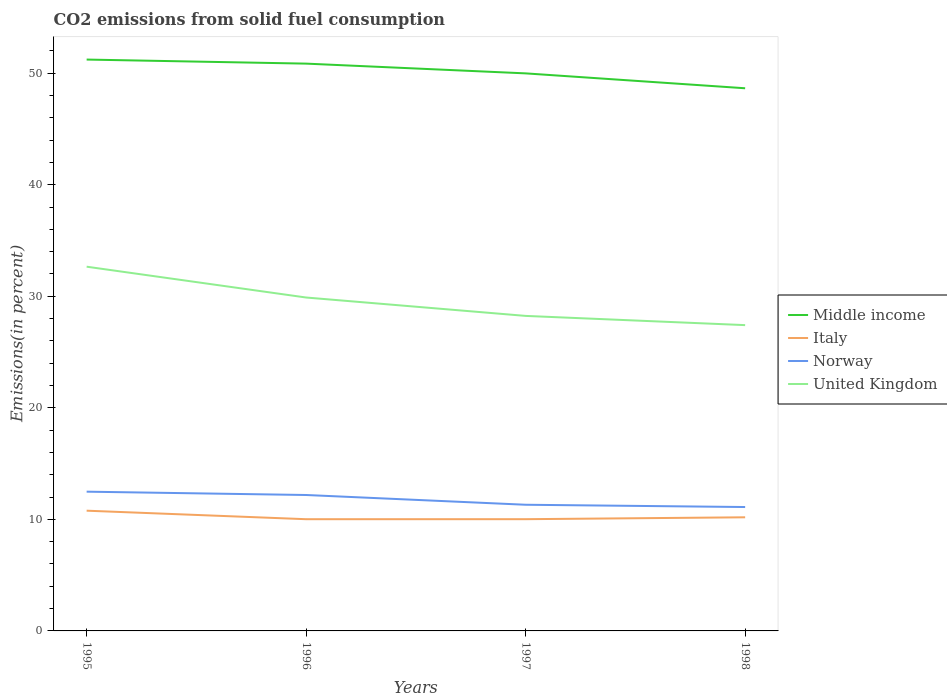Across all years, what is the maximum total CO2 emitted in United Kingdom?
Offer a very short reply. 27.41. In which year was the total CO2 emitted in Norway maximum?
Offer a very short reply. 1998. What is the total total CO2 emitted in Norway in the graph?
Offer a terse response. 0.3. What is the difference between the highest and the second highest total CO2 emitted in United Kingdom?
Your answer should be very brief. 5.24. What is the difference between the highest and the lowest total CO2 emitted in United Kingdom?
Provide a succinct answer. 2. Where does the legend appear in the graph?
Provide a short and direct response. Center right. What is the title of the graph?
Give a very brief answer. CO2 emissions from solid fuel consumption. Does "Slovak Republic" appear as one of the legend labels in the graph?
Offer a terse response. No. What is the label or title of the Y-axis?
Make the answer very short. Emissions(in percent). What is the Emissions(in percent) of Middle income in 1995?
Offer a terse response. 51.22. What is the Emissions(in percent) of Italy in 1995?
Make the answer very short. 10.78. What is the Emissions(in percent) in Norway in 1995?
Provide a short and direct response. 12.48. What is the Emissions(in percent) in United Kingdom in 1995?
Make the answer very short. 32.65. What is the Emissions(in percent) of Middle income in 1996?
Offer a very short reply. 50.85. What is the Emissions(in percent) of Italy in 1996?
Provide a short and direct response. 10.01. What is the Emissions(in percent) of Norway in 1996?
Ensure brevity in your answer.  12.18. What is the Emissions(in percent) of United Kingdom in 1996?
Offer a very short reply. 29.89. What is the Emissions(in percent) in Middle income in 1997?
Give a very brief answer. 49.98. What is the Emissions(in percent) of Italy in 1997?
Provide a succinct answer. 10.02. What is the Emissions(in percent) of Norway in 1997?
Give a very brief answer. 11.31. What is the Emissions(in percent) of United Kingdom in 1997?
Offer a terse response. 28.24. What is the Emissions(in percent) of Middle income in 1998?
Your response must be concise. 48.64. What is the Emissions(in percent) of Italy in 1998?
Your answer should be compact. 10.19. What is the Emissions(in percent) of Norway in 1998?
Keep it short and to the point. 11.11. What is the Emissions(in percent) in United Kingdom in 1998?
Give a very brief answer. 27.41. Across all years, what is the maximum Emissions(in percent) of Middle income?
Offer a terse response. 51.22. Across all years, what is the maximum Emissions(in percent) of Italy?
Provide a succinct answer. 10.78. Across all years, what is the maximum Emissions(in percent) of Norway?
Make the answer very short. 12.48. Across all years, what is the maximum Emissions(in percent) of United Kingdom?
Offer a very short reply. 32.65. Across all years, what is the minimum Emissions(in percent) in Middle income?
Your answer should be very brief. 48.64. Across all years, what is the minimum Emissions(in percent) of Italy?
Keep it short and to the point. 10.01. Across all years, what is the minimum Emissions(in percent) of Norway?
Your answer should be very brief. 11.11. Across all years, what is the minimum Emissions(in percent) of United Kingdom?
Give a very brief answer. 27.41. What is the total Emissions(in percent) in Middle income in the graph?
Give a very brief answer. 200.69. What is the total Emissions(in percent) of Italy in the graph?
Your answer should be very brief. 40.99. What is the total Emissions(in percent) of Norway in the graph?
Offer a terse response. 47.08. What is the total Emissions(in percent) of United Kingdom in the graph?
Make the answer very short. 118.19. What is the difference between the Emissions(in percent) in Middle income in 1995 and that in 1996?
Offer a very short reply. 0.36. What is the difference between the Emissions(in percent) in Italy in 1995 and that in 1996?
Your answer should be very brief. 0.76. What is the difference between the Emissions(in percent) in Norway in 1995 and that in 1996?
Offer a terse response. 0.3. What is the difference between the Emissions(in percent) of United Kingdom in 1995 and that in 1996?
Make the answer very short. 2.76. What is the difference between the Emissions(in percent) of Middle income in 1995 and that in 1997?
Your answer should be compact. 1.24. What is the difference between the Emissions(in percent) of Italy in 1995 and that in 1997?
Provide a short and direct response. 0.76. What is the difference between the Emissions(in percent) of Norway in 1995 and that in 1997?
Provide a succinct answer. 1.17. What is the difference between the Emissions(in percent) in United Kingdom in 1995 and that in 1997?
Provide a short and direct response. 4.41. What is the difference between the Emissions(in percent) of Middle income in 1995 and that in 1998?
Give a very brief answer. 2.57. What is the difference between the Emissions(in percent) in Italy in 1995 and that in 1998?
Your answer should be very brief. 0.59. What is the difference between the Emissions(in percent) in Norway in 1995 and that in 1998?
Your response must be concise. 1.38. What is the difference between the Emissions(in percent) of United Kingdom in 1995 and that in 1998?
Provide a succinct answer. 5.24. What is the difference between the Emissions(in percent) in Middle income in 1996 and that in 1997?
Offer a terse response. 0.87. What is the difference between the Emissions(in percent) in Italy in 1996 and that in 1997?
Give a very brief answer. -0. What is the difference between the Emissions(in percent) in Norway in 1996 and that in 1997?
Your response must be concise. 0.87. What is the difference between the Emissions(in percent) of United Kingdom in 1996 and that in 1997?
Your response must be concise. 1.65. What is the difference between the Emissions(in percent) in Middle income in 1996 and that in 1998?
Provide a short and direct response. 2.21. What is the difference between the Emissions(in percent) in Italy in 1996 and that in 1998?
Your response must be concise. -0.17. What is the difference between the Emissions(in percent) of Norway in 1996 and that in 1998?
Keep it short and to the point. 1.08. What is the difference between the Emissions(in percent) in United Kingdom in 1996 and that in 1998?
Your answer should be compact. 2.48. What is the difference between the Emissions(in percent) in Middle income in 1997 and that in 1998?
Provide a short and direct response. 1.33. What is the difference between the Emissions(in percent) in Italy in 1997 and that in 1998?
Offer a terse response. -0.17. What is the difference between the Emissions(in percent) in Norway in 1997 and that in 1998?
Provide a succinct answer. 0.2. What is the difference between the Emissions(in percent) in United Kingdom in 1997 and that in 1998?
Ensure brevity in your answer.  0.83. What is the difference between the Emissions(in percent) of Middle income in 1995 and the Emissions(in percent) of Italy in 1996?
Your answer should be very brief. 41.2. What is the difference between the Emissions(in percent) in Middle income in 1995 and the Emissions(in percent) in Norway in 1996?
Ensure brevity in your answer.  39.03. What is the difference between the Emissions(in percent) in Middle income in 1995 and the Emissions(in percent) in United Kingdom in 1996?
Your response must be concise. 21.33. What is the difference between the Emissions(in percent) in Italy in 1995 and the Emissions(in percent) in Norway in 1996?
Your answer should be very brief. -1.41. What is the difference between the Emissions(in percent) of Italy in 1995 and the Emissions(in percent) of United Kingdom in 1996?
Your response must be concise. -19.11. What is the difference between the Emissions(in percent) of Norway in 1995 and the Emissions(in percent) of United Kingdom in 1996?
Offer a terse response. -17.4. What is the difference between the Emissions(in percent) in Middle income in 1995 and the Emissions(in percent) in Italy in 1997?
Offer a terse response. 41.2. What is the difference between the Emissions(in percent) of Middle income in 1995 and the Emissions(in percent) of Norway in 1997?
Ensure brevity in your answer.  39.91. What is the difference between the Emissions(in percent) of Middle income in 1995 and the Emissions(in percent) of United Kingdom in 1997?
Offer a very short reply. 22.98. What is the difference between the Emissions(in percent) of Italy in 1995 and the Emissions(in percent) of Norway in 1997?
Make the answer very short. -0.53. What is the difference between the Emissions(in percent) of Italy in 1995 and the Emissions(in percent) of United Kingdom in 1997?
Keep it short and to the point. -17.46. What is the difference between the Emissions(in percent) of Norway in 1995 and the Emissions(in percent) of United Kingdom in 1997?
Keep it short and to the point. -15.76. What is the difference between the Emissions(in percent) in Middle income in 1995 and the Emissions(in percent) in Italy in 1998?
Your answer should be compact. 41.03. What is the difference between the Emissions(in percent) of Middle income in 1995 and the Emissions(in percent) of Norway in 1998?
Your response must be concise. 40.11. What is the difference between the Emissions(in percent) of Middle income in 1995 and the Emissions(in percent) of United Kingdom in 1998?
Provide a succinct answer. 23.81. What is the difference between the Emissions(in percent) of Italy in 1995 and the Emissions(in percent) of Norway in 1998?
Ensure brevity in your answer.  -0.33. What is the difference between the Emissions(in percent) in Italy in 1995 and the Emissions(in percent) in United Kingdom in 1998?
Keep it short and to the point. -16.63. What is the difference between the Emissions(in percent) in Norway in 1995 and the Emissions(in percent) in United Kingdom in 1998?
Your answer should be very brief. -14.93. What is the difference between the Emissions(in percent) in Middle income in 1996 and the Emissions(in percent) in Italy in 1997?
Offer a terse response. 40.84. What is the difference between the Emissions(in percent) of Middle income in 1996 and the Emissions(in percent) of Norway in 1997?
Offer a very short reply. 39.54. What is the difference between the Emissions(in percent) in Middle income in 1996 and the Emissions(in percent) in United Kingdom in 1997?
Provide a short and direct response. 22.61. What is the difference between the Emissions(in percent) in Italy in 1996 and the Emissions(in percent) in Norway in 1997?
Your answer should be compact. -1.3. What is the difference between the Emissions(in percent) of Italy in 1996 and the Emissions(in percent) of United Kingdom in 1997?
Make the answer very short. -18.22. What is the difference between the Emissions(in percent) in Norway in 1996 and the Emissions(in percent) in United Kingdom in 1997?
Make the answer very short. -16.05. What is the difference between the Emissions(in percent) in Middle income in 1996 and the Emissions(in percent) in Italy in 1998?
Provide a succinct answer. 40.67. What is the difference between the Emissions(in percent) in Middle income in 1996 and the Emissions(in percent) in Norway in 1998?
Offer a terse response. 39.75. What is the difference between the Emissions(in percent) of Middle income in 1996 and the Emissions(in percent) of United Kingdom in 1998?
Offer a very short reply. 23.44. What is the difference between the Emissions(in percent) in Italy in 1996 and the Emissions(in percent) in Norway in 1998?
Give a very brief answer. -1.09. What is the difference between the Emissions(in percent) of Italy in 1996 and the Emissions(in percent) of United Kingdom in 1998?
Your answer should be compact. -17.4. What is the difference between the Emissions(in percent) in Norway in 1996 and the Emissions(in percent) in United Kingdom in 1998?
Keep it short and to the point. -15.23. What is the difference between the Emissions(in percent) of Middle income in 1997 and the Emissions(in percent) of Italy in 1998?
Provide a short and direct response. 39.79. What is the difference between the Emissions(in percent) in Middle income in 1997 and the Emissions(in percent) in Norway in 1998?
Provide a short and direct response. 38.87. What is the difference between the Emissions(in percent) in Middle income in 1997 and the Emissions(in percent) in United Kingdom in 1998?
Keep it short and to the point. 22.57. What is the difference between the Emissions(in percent) of Italy in 1997 and the Emissions(in percent) of Norway in 1998?
Provide a succinct answer. -1.09. What is the difference between the Emissions(in percent) in Italy in 1997 and the Emissions(in percent) in United Kingdom in 1998?
Make the answer very short. -17.4. What is the difference between the Emissions(in percent) in Norway in 1997 and the Emissions(in percent) in United Kingdom in 1998?
Your response must be concise. -16.1. What is the average Emissions(in percent) of Middle income per year?
Your response must be concise. 50.17. What is the average Emissions(in percent) of Italy per year?
Make the answer very short. 10.25. What is the average Emissions(in percent) of Norway per year?
Provide a short and direct response. 11.77. What is the average Emissions(in percent) in United Kingdom per year?
Make the answer very short. 29.55. In the year 1995, what is the difference between the Emissions(in percent) in Middle income and Emissions(in percent) in Italy?
Provide a short and direct response. 40.44. In the year 1995, what is the difference between the Emissions(in percent) in Middle income and Emissions(in percent) in Norway?
Provide a short and direct response. 38.74. In the year 1995, what is the difference between the Emissions(in percent) in Middle income and Emissions(in percent) in United Kingdom?
Your answer should be compact. 18.57. In the year 1995, what is the difference between the Emissions(in percent) in Italy and Emissions(in percent) in Norway?
Your answer should be very brief. -1.71. In the year 1995, what is the difference between the Emissions(in percent) in Italy and Emissions(in percent) in United Kingdom?
Ensure brevity in your answer.  -21.87. In the year 1995, what is the difference between the Emissions(in percent) of Norway and Emissions(in percent) of United Kingdom?
Make the answer very short. -20.17. In the year 1996, what is the difference between the Emissions(in percent) of Middle income and Emissions(in percent) of Italy?
Offer a very short reply. 40.84. In the year 1996, what is the difference between the Emissions(in percent) in Middle income and Emissions(in percent) in Norway?
Give a very brief answer. 38.67. In the year 1996, what is the difference between the Emissions(in percent) in Middle income and Emissions(in percent) in United Kingdom?
Ensure brevity in your answer.  20.97. In the year 1996, what is the difference between the Emissions(in percent) in Italy and Emissions(in percent) in Norway?
Your answer should be compact. -2.17. In the year 1996, what is the difference between the Emissions(in percent) of Italy and Emissions(in percent) of United Kingdom?
Ensure brevity in your answer.  -19.87. In the year 1996, what is the difference between the Emissions(in percent) in Norway and Emissions(in percent) in United Kingdom?
Offer a terse response. -17.7. In the year 1997, what is the difference between the Emissions(in percent) in Middle income and Emissions(in percent) in Italy?
Provide a short and direct response. 39.96. In the year 1997, what is the difference between the Emissions(in percent) of Middle income and Emissions(in percent) of Norway?
Provide a succinct answer. 38.67. In the year 1997, what is the difference between the Emissions(in percent) of Middle income and Emissions(in percent) of United Kingdom?
Keep it short and to the point. 21.74. In the year 1997, what is the difference between the Emissions(in percent) of Italy and Emissions(in percent) of Norway?
Your answer should be very brief. -1.29. In the year 1997, what is the difference between the Emissions(in percent) in Italy and Emissions(in percent) in United Kingdom?
Your answer should be compact. -18.22. In the year 1997, what is the difference between the Emissions(in percent) of Norway and Emissions(in percent) of United Kingdom?
Provide a succinct answer. -16.93. In the year 1998, what is the difference between the Emissions(in percent) in Middle income and Emissions(in percent) in Italy?
Offer a very short reply. 38.46. In the year 1998, what is the difference between the Emissions(in percent) in Middle income and Emissions(in percent) in Norway?
Give a very brief answer. 37.54. In the year 1998, what is the difference between the Emissions(in percent) in Middle income and Emissions(in percent) in United Kingdom?
Provide a short and direct response. 21.23. In the year 1998, what is the difference between the Emissions(in percent) in Italy and Emissions(in percent) in Norway?
Make the answer very short. -0.92. In the year 1998, what is the difference between the Emissions(in percent) of Italy and Emissions(in percent) of United Kingdom?
Offer a very short reply. -17.23. In the year 1998, what is the difference between the Emissions(in percent) of Norway and Emissions(in percent) of United Kingdom?
Make the answer very short. -16.31. What is the ratio of the Emissions(in percent) in Middle income in 1995 to that in 1996?
Provide a short and direct response. 1.01. What is the ratio of the Emissions(in percent) of Italy in 1995 to that in 1996?
Keep it short and to the point. 1.08. What is the ratio of the Emissions(in percent) in Norway in 1995 to that in 1996?
Offer a very short reply. 1.02. What is the ratio of the Emissions(in percent) of United Kingdom in 1995 to that in 1996?
Give a very brief answer. 1.09. What is the ratio of the Emissions(in percent) of Middle income in 1995 to that in 1997?
Offer a terse response. 1.02. What is the ratio of the Emissions(in percent) of Italy in 1995 to that in 1997?
Your answer should be very brief. 1.08. What is the ratio of the Emissions(in percent) of Norway in 1995 to that in 1997?
Offer a terse response. 1.1. What is the ratio of the Emissions(in percent) in United Kingdom in 1995 to that in 1997?
Your answer should be very brief. 1.16. What is the ratio of the Emissions(in percent) of Middle income in 1995 to that in 1998?
Provide a succinct answer. 1.05. What is the ratio of the Emissions(in percent) in Italy in 1995 to that in 1998?
Make the answer very short. 1.06. What is the ratio of the Emissions(in percent) of Norway in 1995 to that in 1998?
Your answer should be compact. 1.12. What is the ratio of the Emissions(in percent) in United Kingdom in 1995 to that in 1998?
Your answer should be compact. 1.19. What is the ratio of the Emissions(in percent) in Middle income in 1996 to that in 1997?
Keep it short and to the point. 1.02. What is the ratio of the Emissions(in percent) in Italy in 1996 to that in 1997?
Your response must be concise. 1. What is the ratio of the Emissions(in percent) in Norway in 1996 to that in 1997?
Your response must be concise. 1.08. What is the ratio of the Emissions(in percent) in United Kingdom in 1996 to that in 1997?
Ensure brevity in your answer.  1.06. What is the ratio of the Emissions(in percent) in Middle income in 1996 to that in 1998?
Make the answer very short. 1.05. What is the ratio of the Emissions(in percent) in Italy in 1996 to that in 1998?
Give a very brief answer. 0.98. What is the ratio of the Emissions(in percent) in Norway in 1996 to that in 1998?
Keep it short and to the point. 1.1. What is the ratio of the Emissions(in percent) in United Kingdom in 1996 to that in 1998?
Give a very brief answer. 1.09. What is the ratio of the Emissions(in percent) of Middle income in 1997 to that in 1998?
Provide a short and direct response. 1.03. What is the ratio of the Emissions(in percent) in Italy in 1997 to that in 1998?
Ensure brevity in your answer.  0.98. What is the ratio of the Emissions(in percent) of Norway in 1997 to that in 1998?
Your response must be concise. 1.02. What is the ratio of the Emissions(in percent) of United Kingdom in 1997 to that in 1998?
Your response must be concise. 1.03. What is the difference between the highest and the second highest Emissions(in percent) in Middle income?
Your answer should be compact. 0.36. What is the difference between the highest and the second highest Emissions(in percent) of Italy?
Offer a very short reply. 0.59. What is the difference between the highest and the second highest Emissions(in percent) of Norway?
Provide a succinct answer. 0.3. What is the difference between the highest and the second highest Emissions(in percent) in United Kingdom?
Offer a terse response. 2.76. What is the difference between the highest and the lowest Emissions(in percent) in Middle income?
Your answer should be very brief. 2.57. What is the difference between the highest and the lowest Emissions(in percent) of Italy?
Ensure brevity in your answer.  0.76. What is the difference between the highest and the lowest Emissions(in percent) of Norway?
Ensure brevity in your answer.  1.38. What is the difference between the highest and the lowest Emissions(in percent) in United Kingdom?
Offer a terse response. 5.24. 